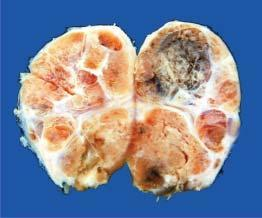what are also seen?
Answer the question using a single word or phrase. Areas of haemorrhage and cystic change 